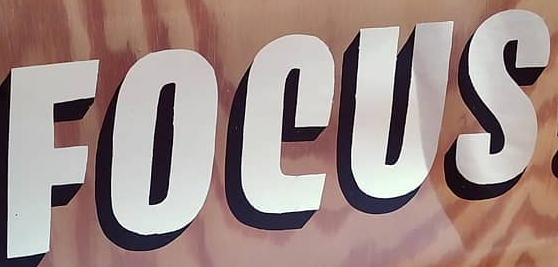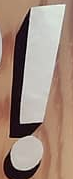What text is displayed in these images sequentially, separated by a semicolon? FOCUS; ! 